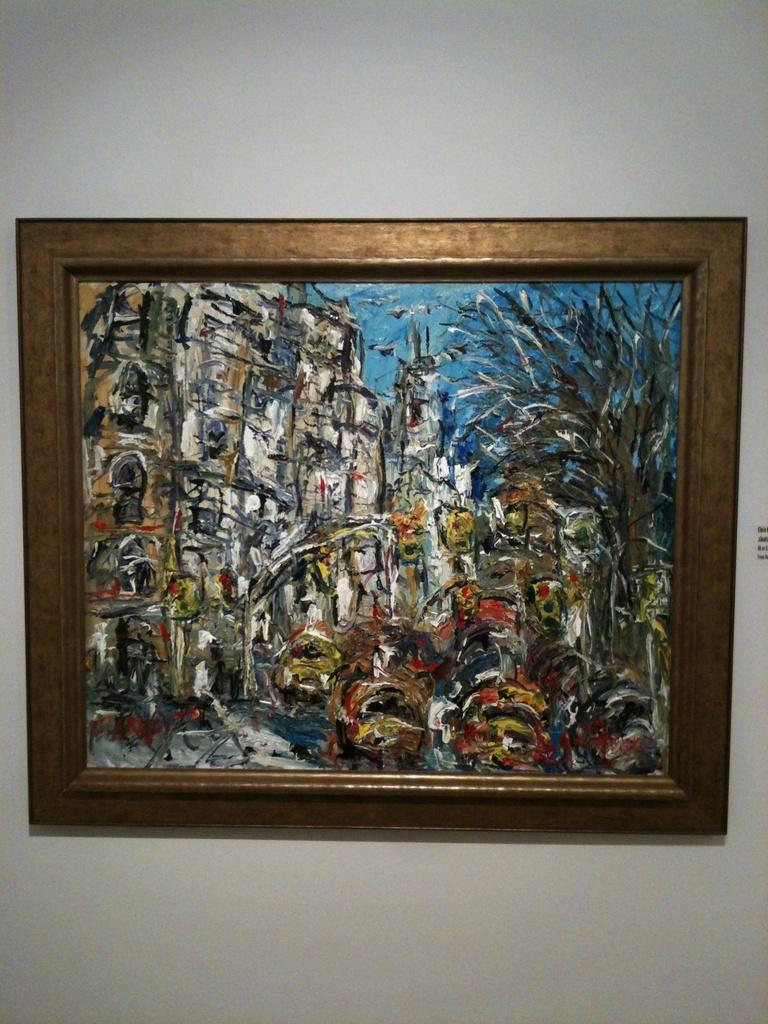What is the main subject in the image? There is a painting in the image. Where is the painting located? The painting is attached to a wall. What type of map is visible in the painting? There is no map present in the painting or the image. 